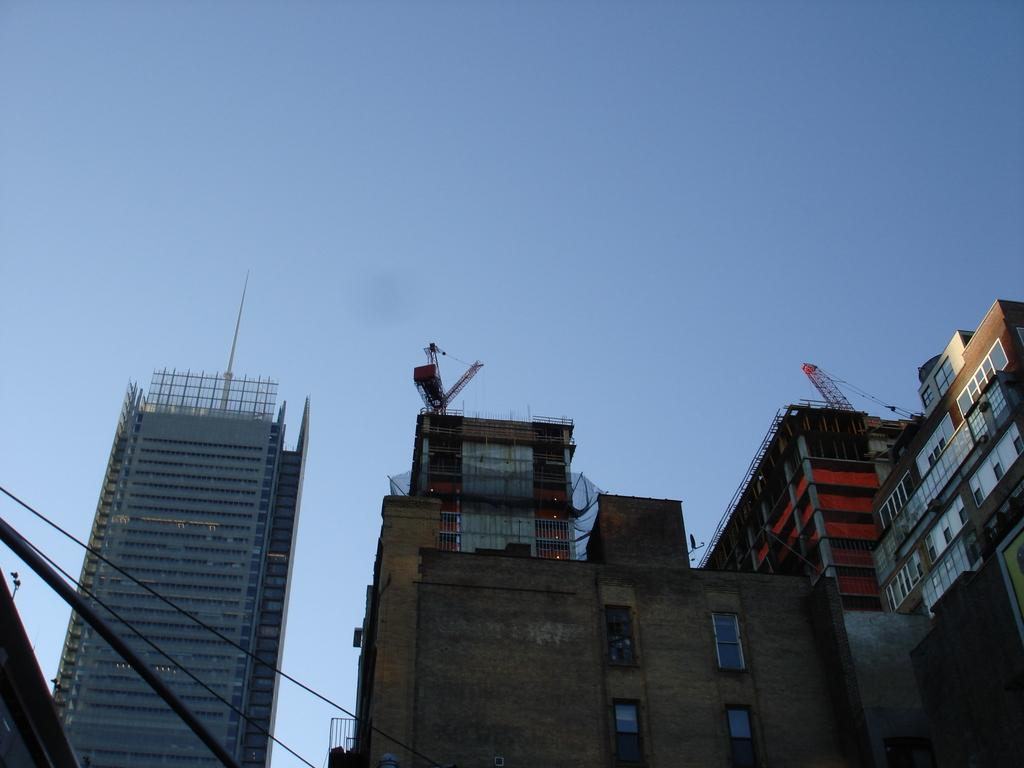What type of structures are visible in the image? There are tower buildings in the image. What objects are present that might be used for lifting or moving heavy items? There are ropes and cranes in the image. What color is the sky in the background of the image? The sky in the background of the image is a plain blue color. Can you see the process of the construction workers' toes in the image? There is no visible process of construction workers' toes in the image. 